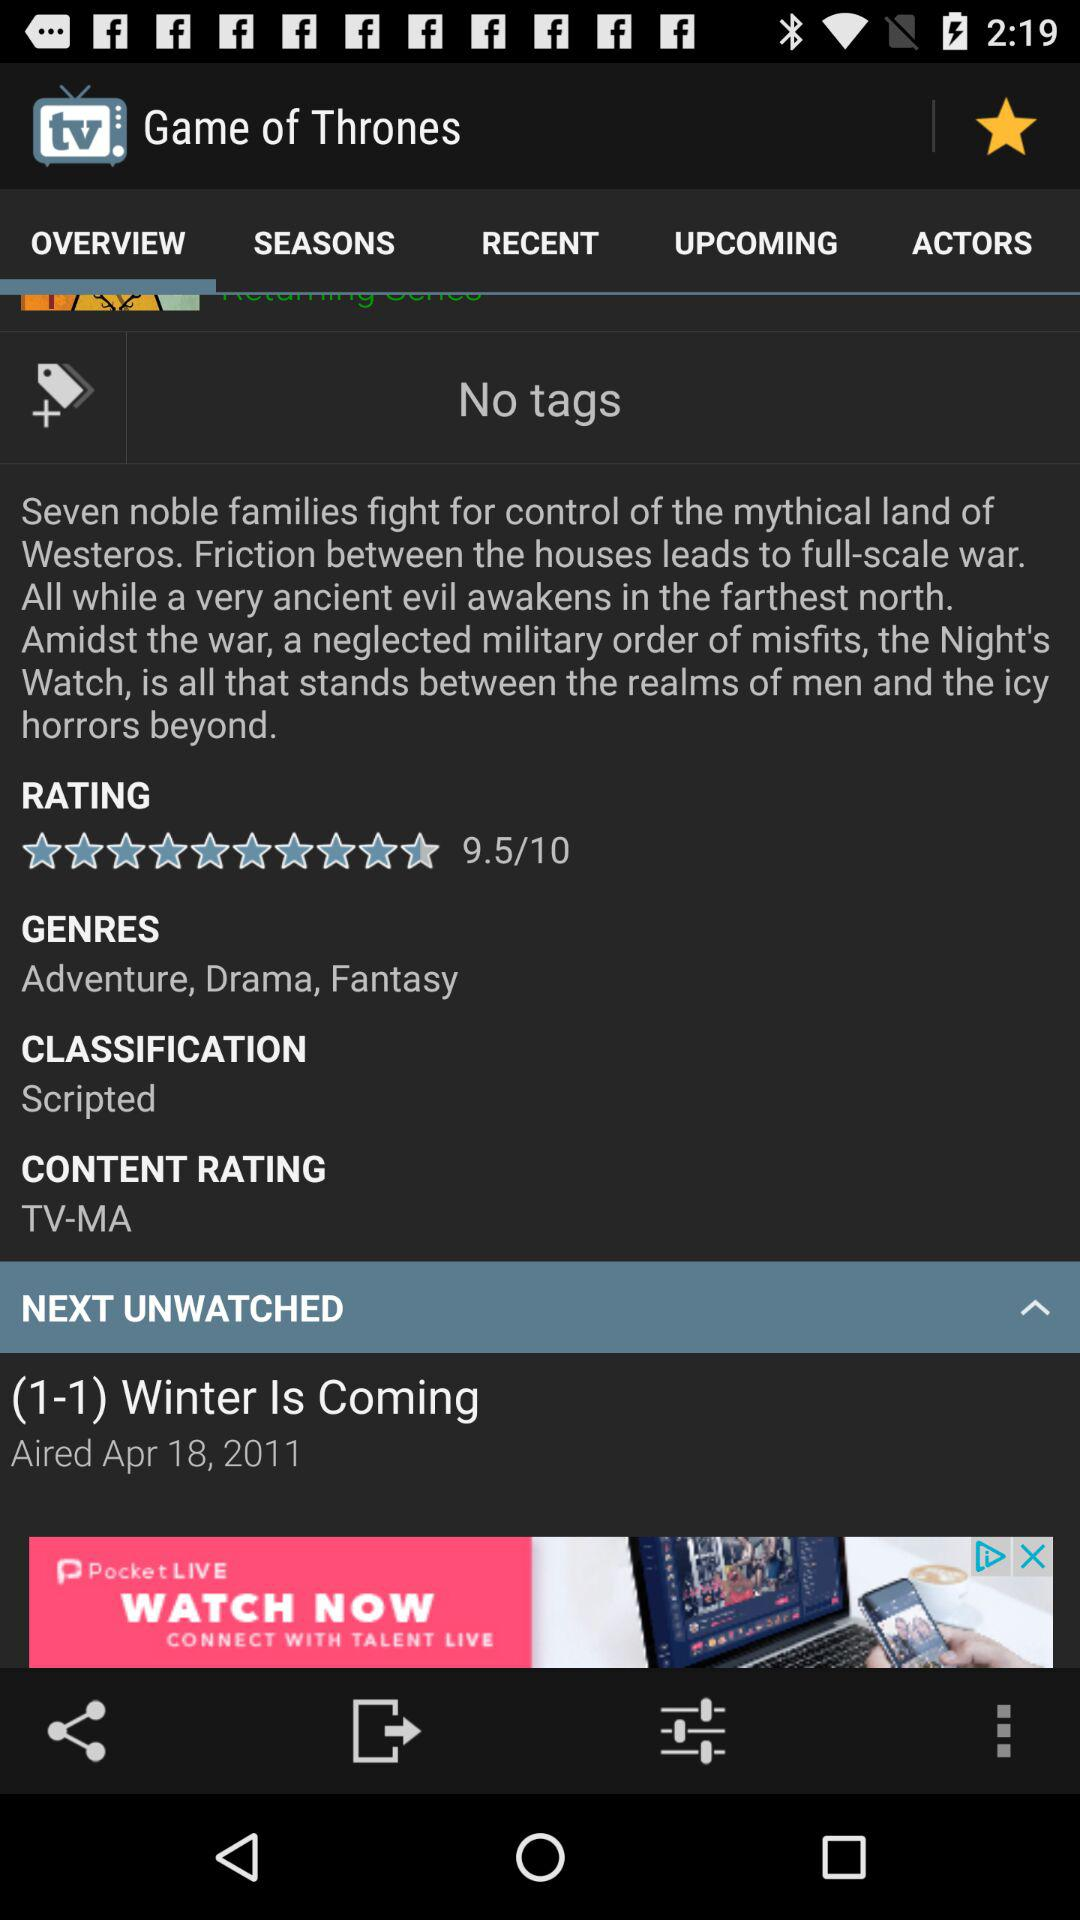What is the content rating? The content rating is TV-MA. 